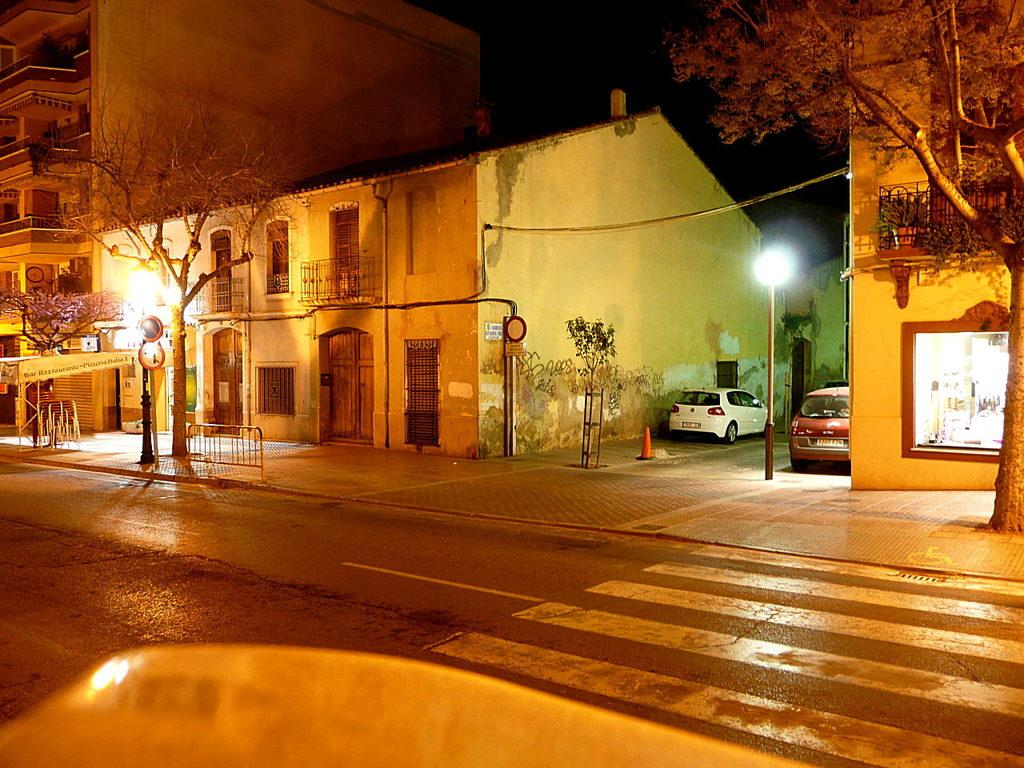What is located at the bottom of the image? There is an object at the bottom of the image. What can be seen in the image besides the object at the bottom? There is a road, poles, vehicles, trees, buildings, and a dark sky in the background of the image. What type of infrastructure is present in the image? The image features roads, poles, and buildings. What type of environment is depicted in the image? The image shows an urban environment with trees and buildings. What type of soda is being served from the poles in the image? There is no soda being served from the poles in the image; they are likely utility poles. How does the steam from the vehicles affect the visibility in the image? There is no steam present in the image; the vehicles are not emitting any visible exhaust. 